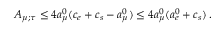<formula> <loc_0><loc_0><loc_500><loc_500>A _ { \mu ; \tau } \leq 4 a _ { \mu } ^ { 0 } ( c _ { e } + c _ { s } - a _ { \mu } ^ { 0 } ) \leq 4 a _ { \mu } ^ { 0 } ( a _ { e } ^ { 0 } + c _ { s } ) \, .</formula> 